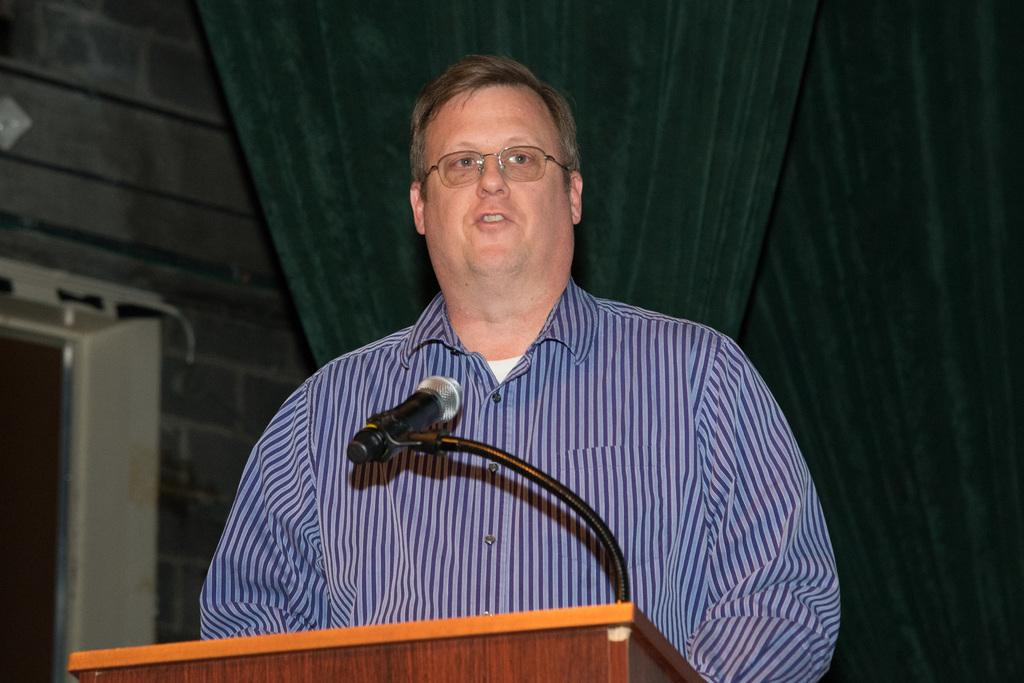What is the man in the image doing near the podium? The man is standing near a podium and holding a mic. What might the man be doing with the mic? The man might be giving a speech or presentation, as he is holding a mic near a podium. What can be seen in the background of the image? There is a curtain, a wall, and a white color object in the background of the image. Can you describe the white color object in the background? Unfortunately, the facts provided do not give enough information to describe the white color object in the background. What type of punishment is the man receiving for his actions in the image? There is no indication of any punishment in the image; the man is simply standing near a podium holding a mic. Can you tell me how many bats are flying around the man in the image? There are no bats present in the image; the facts provided do not mention any bats. 